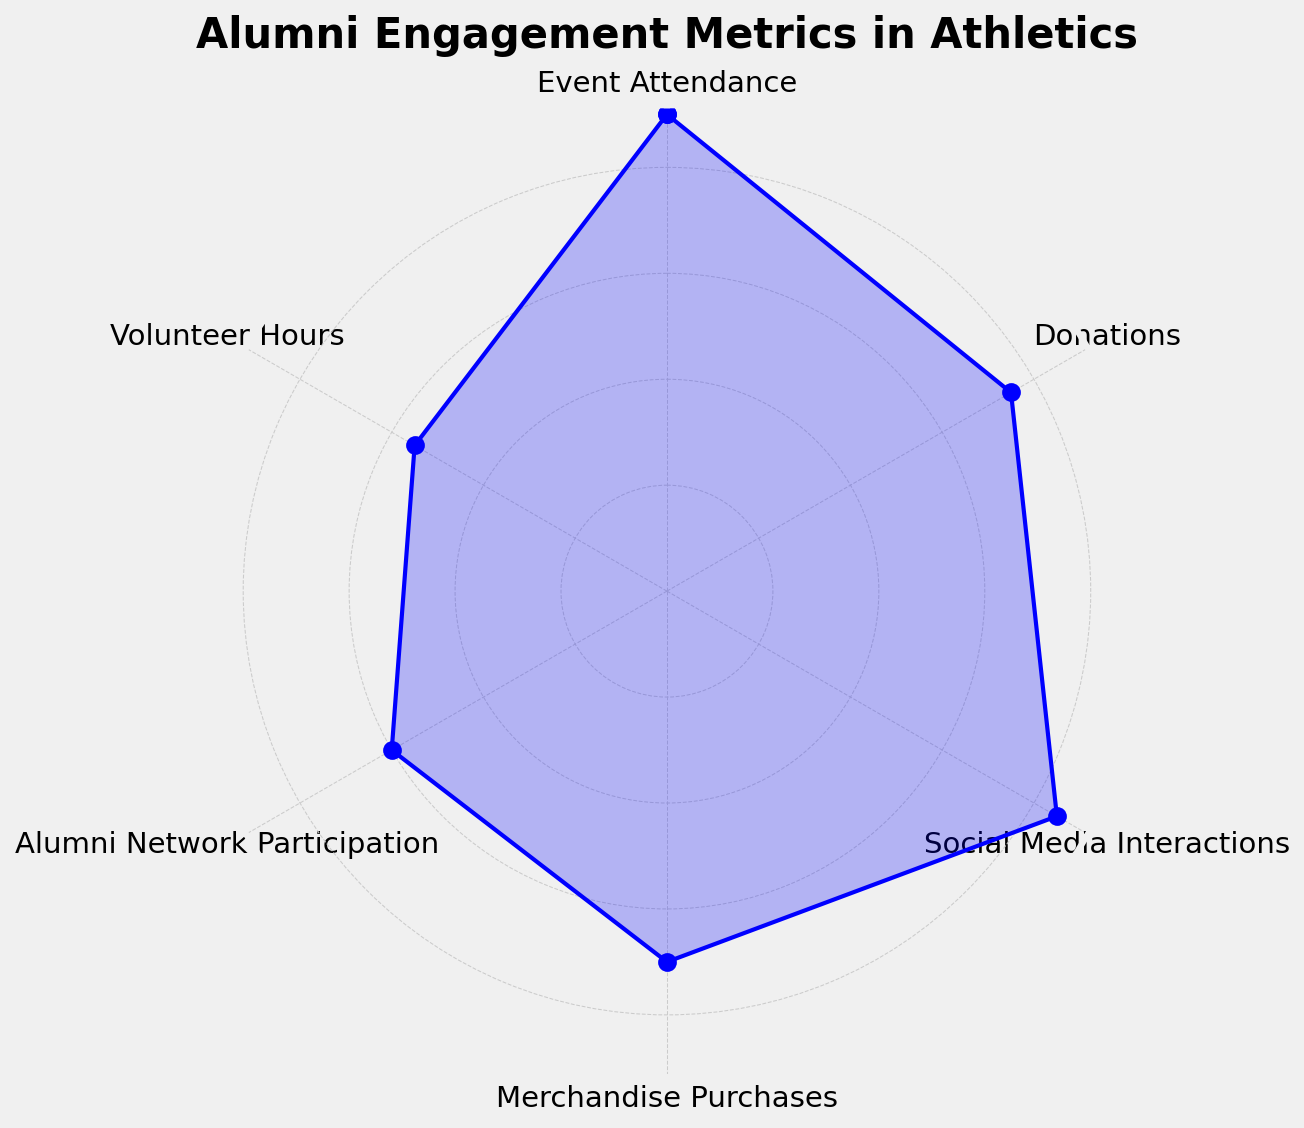what is the average value of all categories? Sum all category values: 90 (Event Attendance) + 75 (Donations) + 85 (Social Media Interactions) + 70 (Merchandise Purchases) + 60 (Alumni Network Participation) + 55 (Volunteer Hours) = 435. There are 6 categories, so the average is 435 / 6 = 72.5
Answer: 72.5 which category has the highest engagement value? Referring to the chart, Event Attendance has the highest engagement value at 90.
Answer: Event Attendance which category has the lowest engagement value? Referring to the chart, Volunteer Hours has the lowest engagement value at 55.
Answer: Volunteer Hours how much greater is the value of Event Attendance compared to Donations? The value of Event Attendance is 90, and Donations is 75. The difference is 90 - 75 = 15.
Answer: 15 what is the middle range value between the highest and lowest values shown? The highest value is 90 (Event Attendance) and the lowest is 55 (Volunteer Hours). To find the middle range value, (90 + 55) / 2 = 72.5.
Answer: 72.5 which two categories have engagement values closest to each other? By visual inspection, the categories with the closest values are Donations (75) and Merchandise Purchases (70), with a difference of 5.
Answer: Donations and Merchandise Purchases order the categories from highest to lowest engagement value Event Attendance (90), Social Media Interactions (85), Donations (75), Merchandise Purchases (70), Alumni Network Participation (60), Volunteer Hours (55)
Answer: Event Attendance, Social Media Interactions, Donations, Merchandise Purchases, Alumni Network Participation, Volunteer Hours 